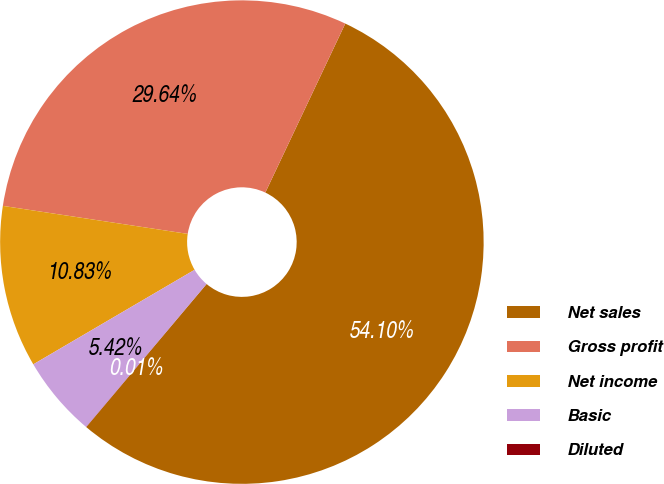<chart> <loc_0><loc_0><loc_500><loc_500><pie_chart><fcel>Net sales<fcel>Gross profit<fcel>Net income<fcel>Basic<fcel>Diluted<nl><fcel>54.1%<fcel>29.64%<fcel>10.83%<fcel>5.42%<fcel>0.01%<nl></chart> 